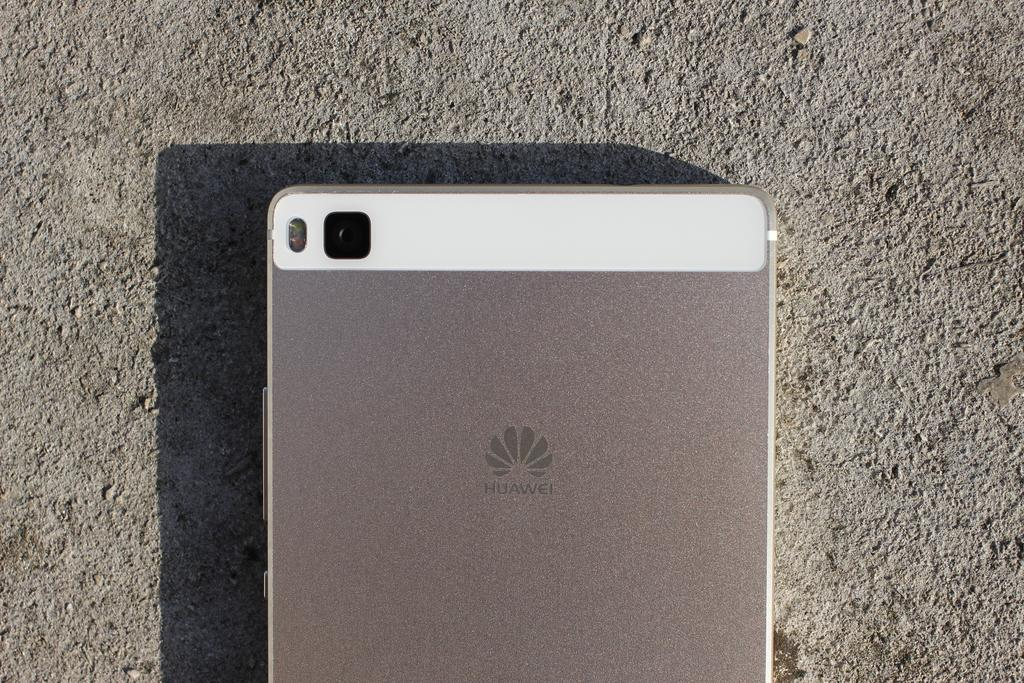<image>
Share a concise interpretation of the image provided. the back of a silver huawei phone with a white trim 